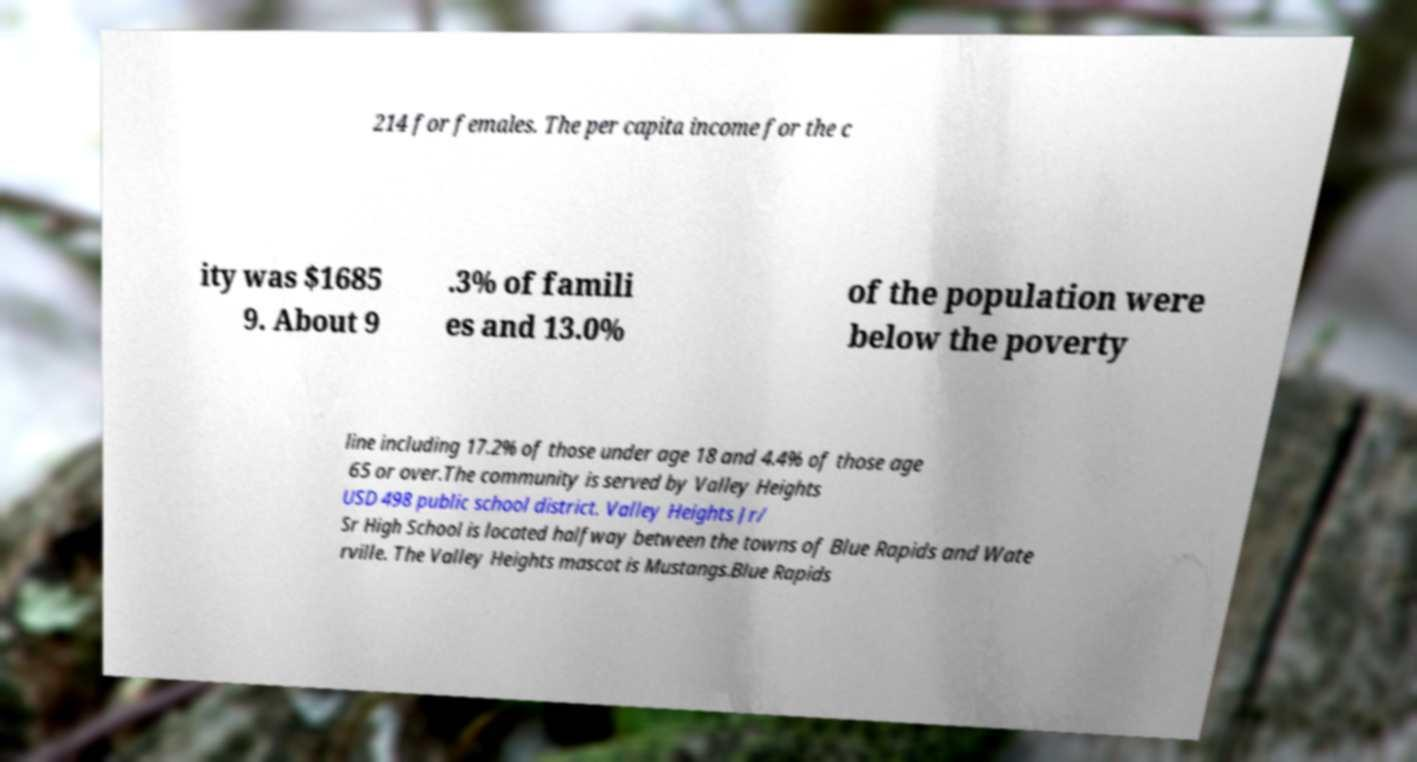What messages or text are displayed in this image? I need them in a readable, typed format. 214 for females. The per capita income for the c ity was $1685 9. About 9 .3% of famili es and 13.0% of the population were below the poverty line including 17.2% of those under age 18 and 4.4% of those age 65 or over.The community is served by Valley Heights USD 498 public school district. Valley Heights Jr/ Sr High School is located halfway between the towns of Blue Rapids and Wate rville. The Valley Heights mascot is Mustangs.Blue Rapids 